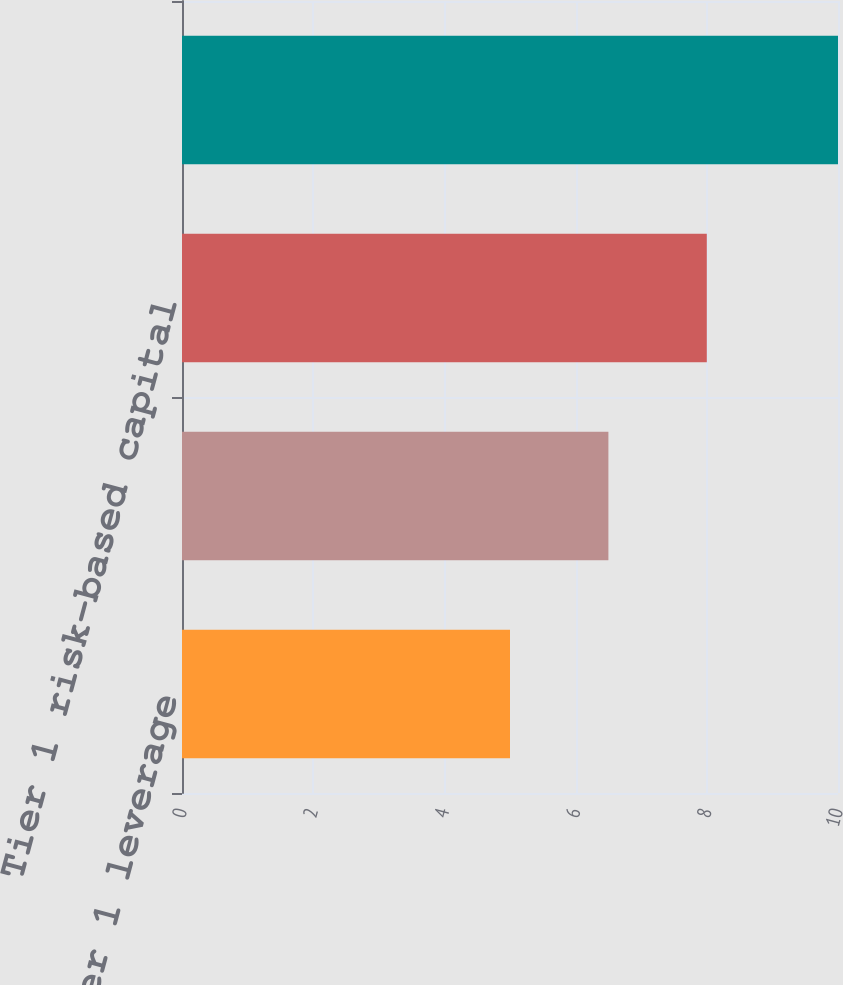Convert chart. <chart><loc_0><loc_0><loc_500><loc_500><bar_chart><fcel>Tier 1 leverage<fcel>Common equity Tier 1 capital<fcel>Tier 1 risk-based capital<fcel>Total risk-based capital<nl><fcel>5<fcel>6.5<fcel>8<fcel>10<nl></chart> 